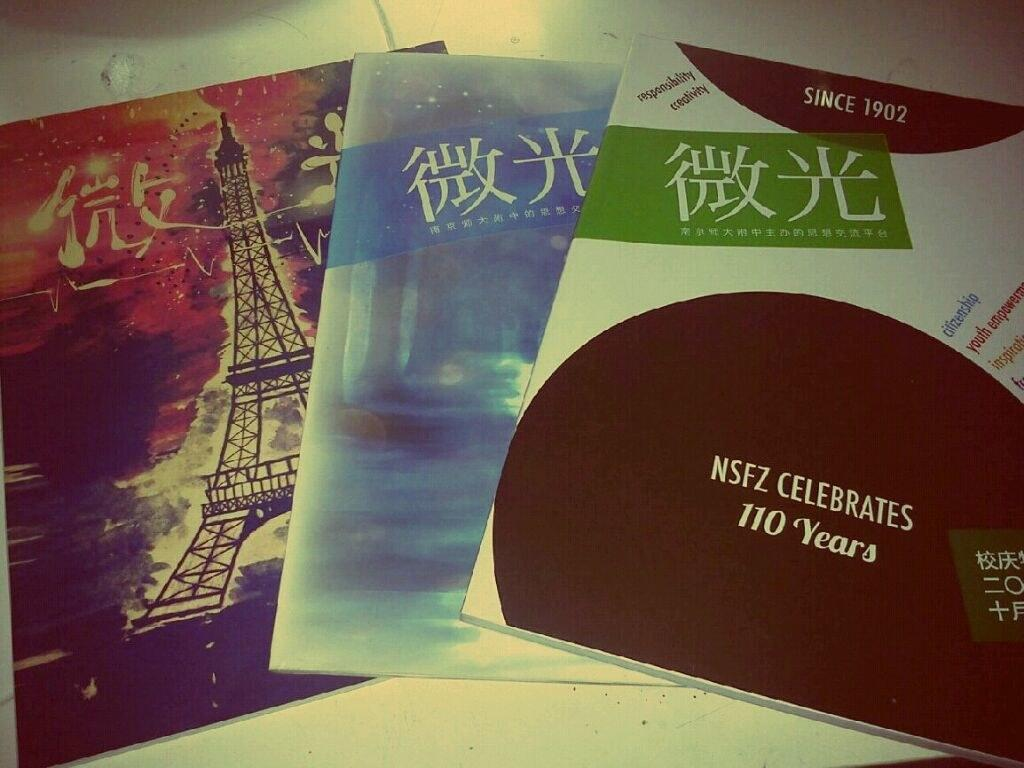<image>
Summarize the visual content of the image. The company is celebrating a 110 years of doing business 